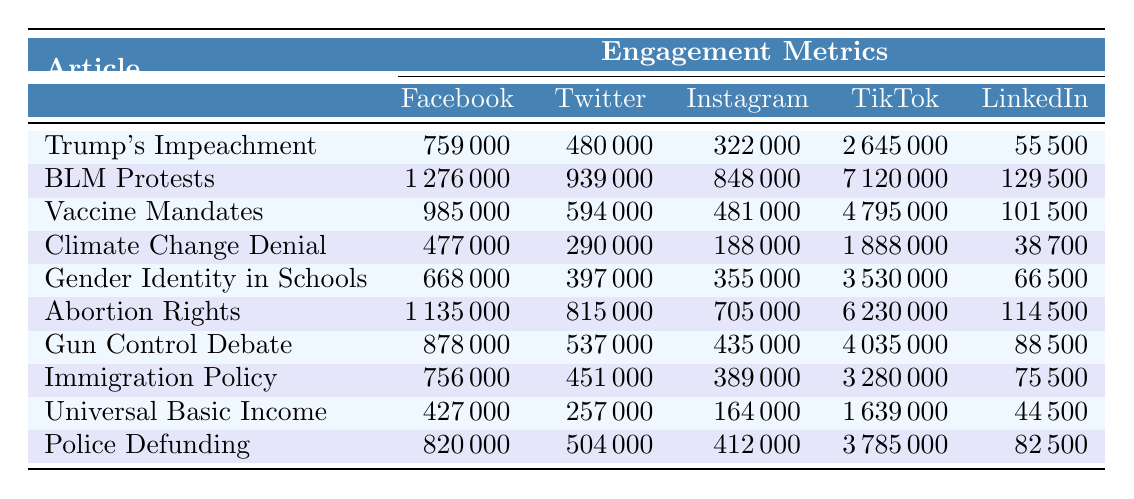What article had the highest engagement on TikTok? Looking at the TikTok engagement metrics, "Black Lives Matter Protests" has the highest views with 7,120,000. Therefore, it has the highest engagement on TikTok.
Answer: Black Lives Matter Protests Which article received the most reactions on Facebook? Checking the Facebook reactions for each article, "Black Lives Matter Protests" has 890,000 reactions, which is the highest among all articles.
Answer: Black Lives Matter Protests Calculate the average likes from Instagram across all articles. The total likes from Instagram for all articles are (280000 + 750000 + 420000 + 160000 + 310000 + 620000 + 380000 + 340000 + 140000 + 360000) = 3,488,000. There are 10 articles, so the average is 3,488,000 / 10 = 348,800.
Answer: 348800 Did "Abortion Rights" get more likes on Instagram than "Gun Control Debate"? "Abortion Rights" received 620,000 likes on Instagram, while "Gun Control Debate" received 380,000 likes. Since 620,000 is greater than 380,000, the statement is true.
Answer: Yes What is the sum of shares on Facebook and LinkedIn for "COVID-19 Vaccine Mandates"? For "COVID-19 Vaccine Mandates," Facebook shares are 180,000 and LinkedIn shares are 22,000. Adding them together gives 180,000 + 22,000 = 202,000.
Answer: 202000 Which article had the least amount of shares on Facebook? Evaluating the Facebook shares for each article, "Universal Basic Income" has the lowest with 85,000 shares compared to other articles.
Answer: Universal Basic Income Is the total engagement on all platforms for "Gender Identity in Schools" greater than that for "Police Defunding"? For "Gender Identity in Schools," the total engagement is (668,000 from Facebook + 397,000 from Twitter + 355,000 from Instagram + 3,530,000 from TikTok + 66,500 from LinkedIn) = 5,016,500. For "Police Defunding," the total is (820,000 + 504,000 + 412,000 + 3,785,000 + 82,500) = 4,613,500. Since 5,016,500 is greater than 4,613,500, this statement is true.
Answer: Yes What is the difference in Facebook shares between "Trump's Impeachment" and "Climate Change Denial"? "Trump's Impeachment" has 150,000 shares on Facebook and "Climate Change Denial" has 95,000. The difference is 150,000 - 95,000 = 55,000.
Answer: 55000 Which platform had the highest engagement for "Black Lives Matter Protests"? Checking for "Black Lives Matter Protests," TikTok had the highest engagement with 7,120,000 views, significantly more than any other platform.
Answer: TikTok Calculate the average sum of comments on Facebook for the articles. Total comments across all articles on Facebook are (89,000 + 156,000 + 125,000 + 72,000 + 98,000 + 145,000 + 118,000 + 96,000 + 62,000 + 110,000) = 1,043,000. With 10 articles, the average is 1,043,000 / 10 = 104,300.
Answer: 104300 